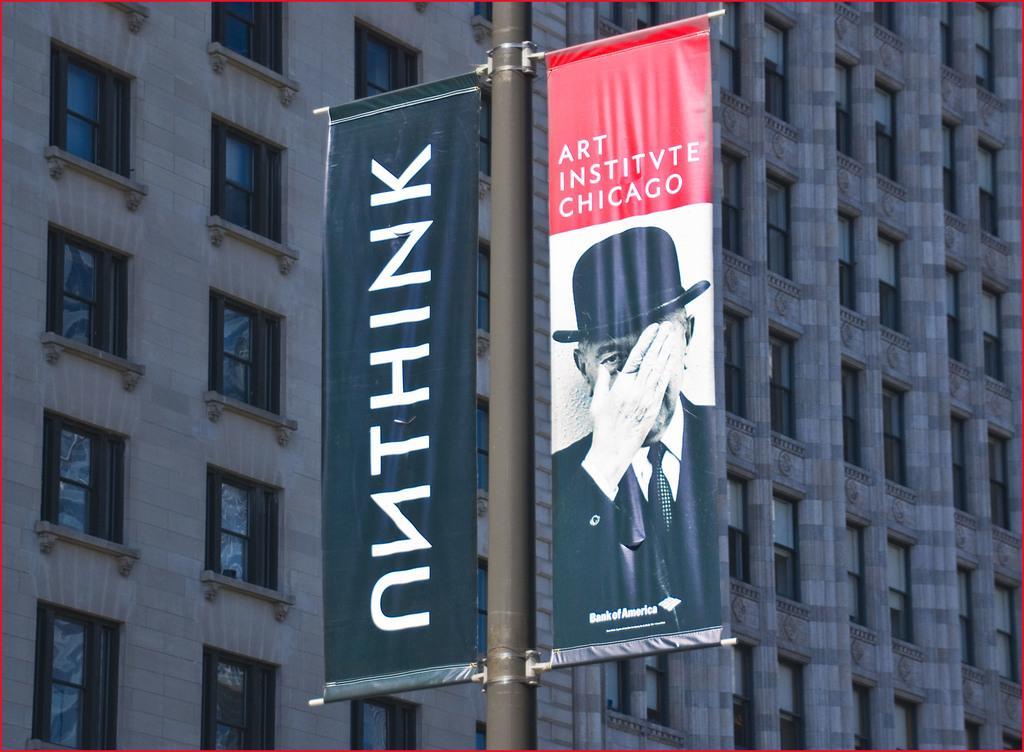Please provide a concise description of this image. This picture seems to be an edited image and the picture is clicked outside. In the center we can see a pole and the banners attached to the pole and we can see the text and a picture of a person wearing suit and hat on the banners. In the background we can see the building and the windows of the building. 